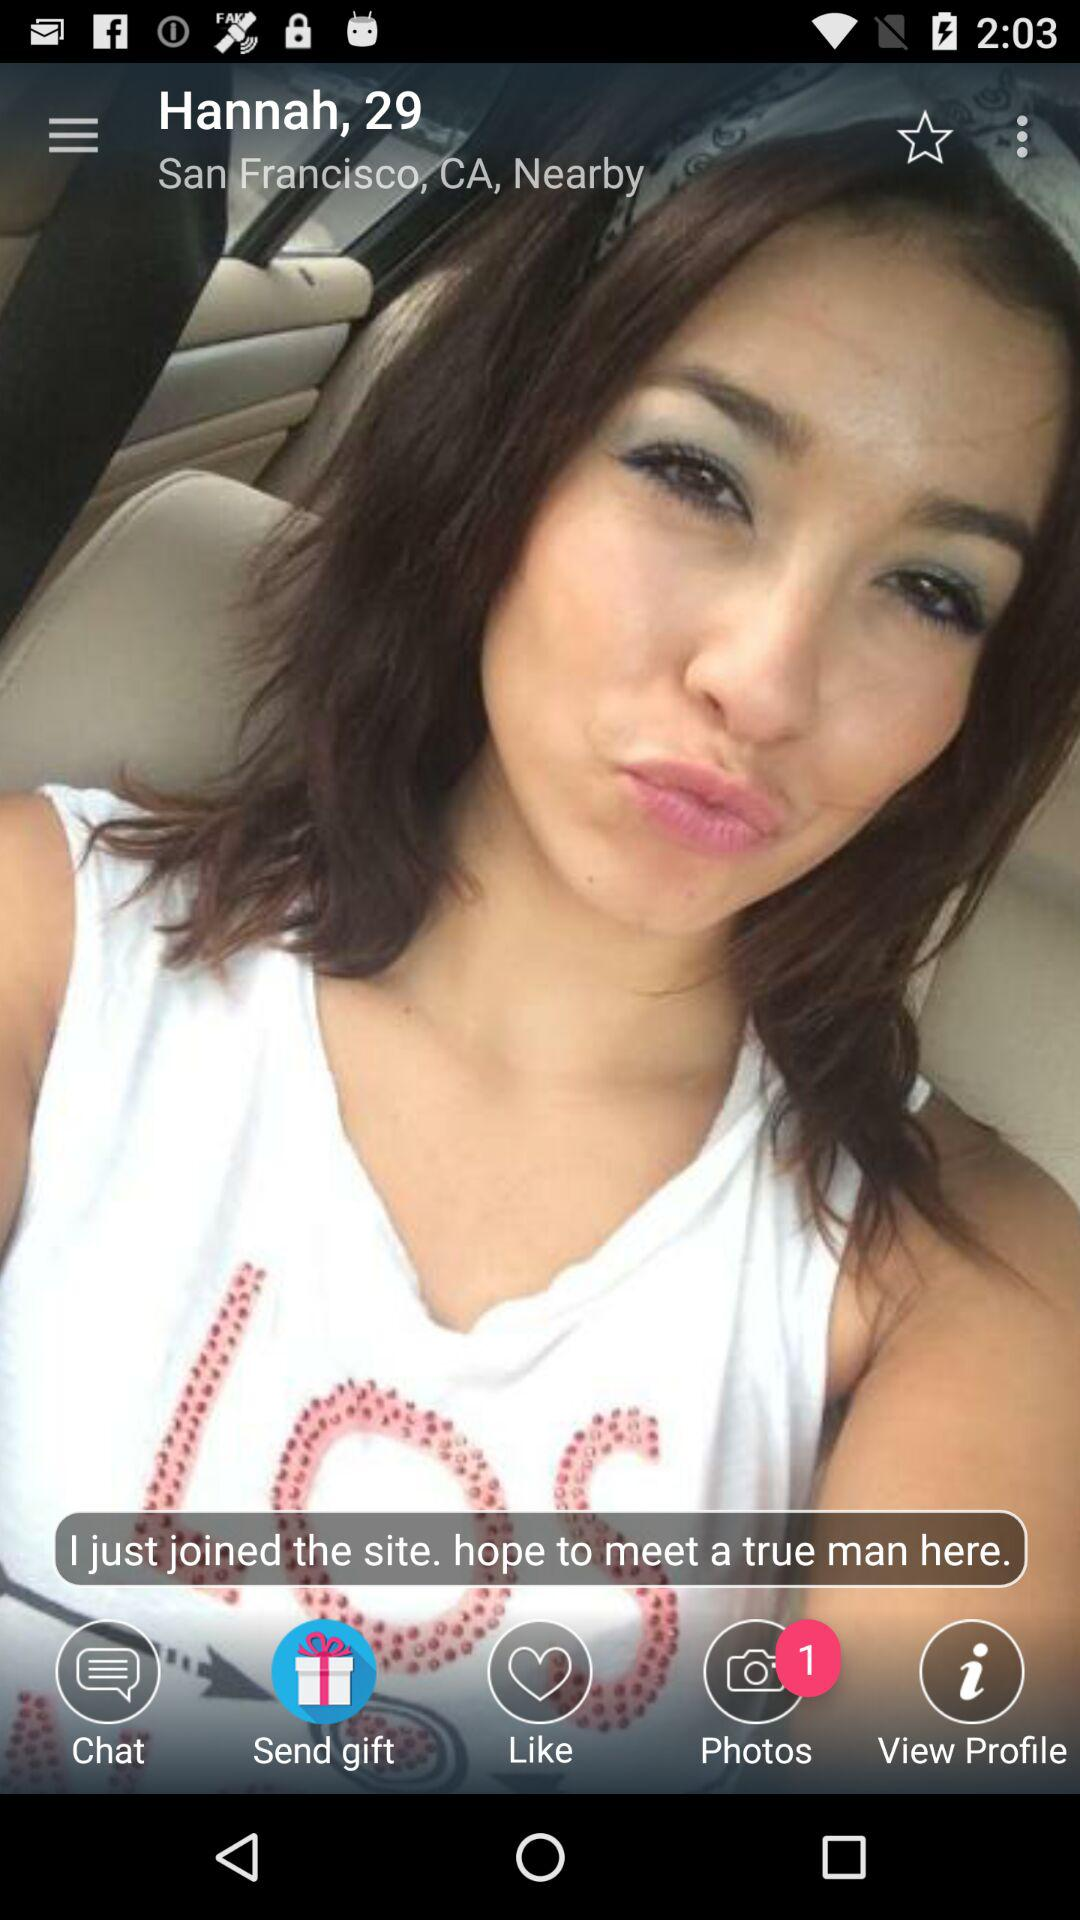What is the name of the person shown on the screen? The name of the person is Hannah. 